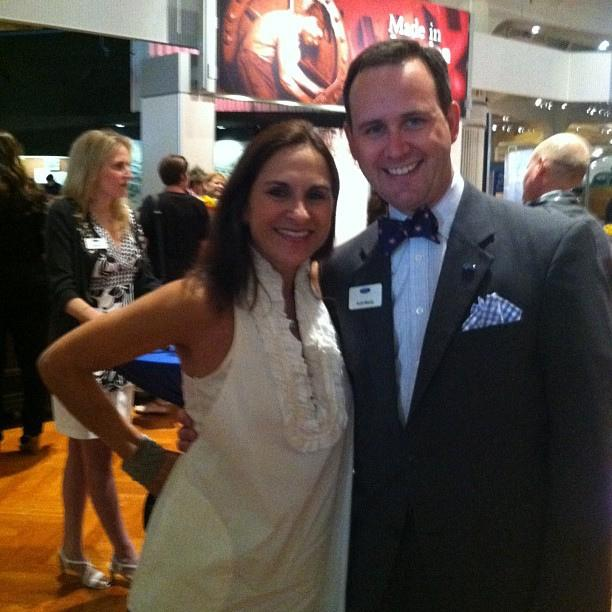At which event do these people pose?

Choices:
A) exhibition
B) mall
C) office meeting
D) zoo exhibition 